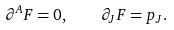<formula> <loc_0><loc_0><loc_500><loc_500>\partial ^ { A } F = 0 , \quad \partial _ { J } F = p _ { J } .</formula> 